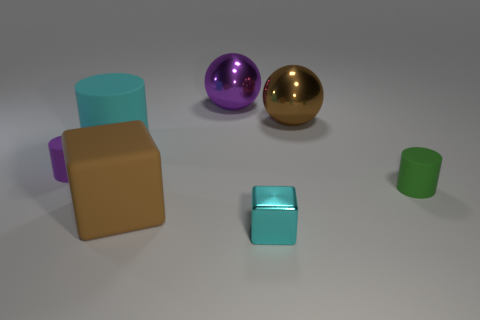Subtract all purple rubber cylinders. How many cylinders are left? 2 Subtract 1 balls. How many balls are left? 1 Subtract all cylinders. How many objects are left? 4 Subtract all cyan cylinders. How many cylinders are left? 2 Subtract 1 brown blocks. How many objects are left? 6 Subtract all cyan cubes. Subtract all brown cylinders. How many cubes are left? 1 Subtract all purple cylinders. How many brown spheres are left? 1 Subtract all large spheres. Subtract all small purple rubber cylinders. How many objects are left? 4 Add 7 big cyan rubber objects. How many big cyan rubber objects are left? 8 Add 5 cyan cylinders. How many cyan cylinders exist? 6 